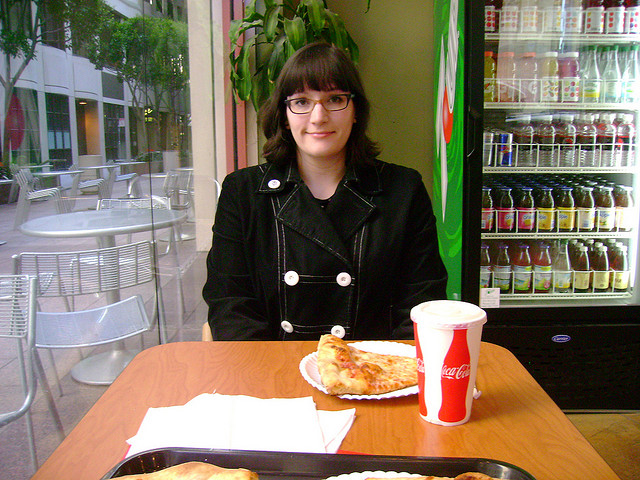Identify and read out the text in this image. COCA-COLA 